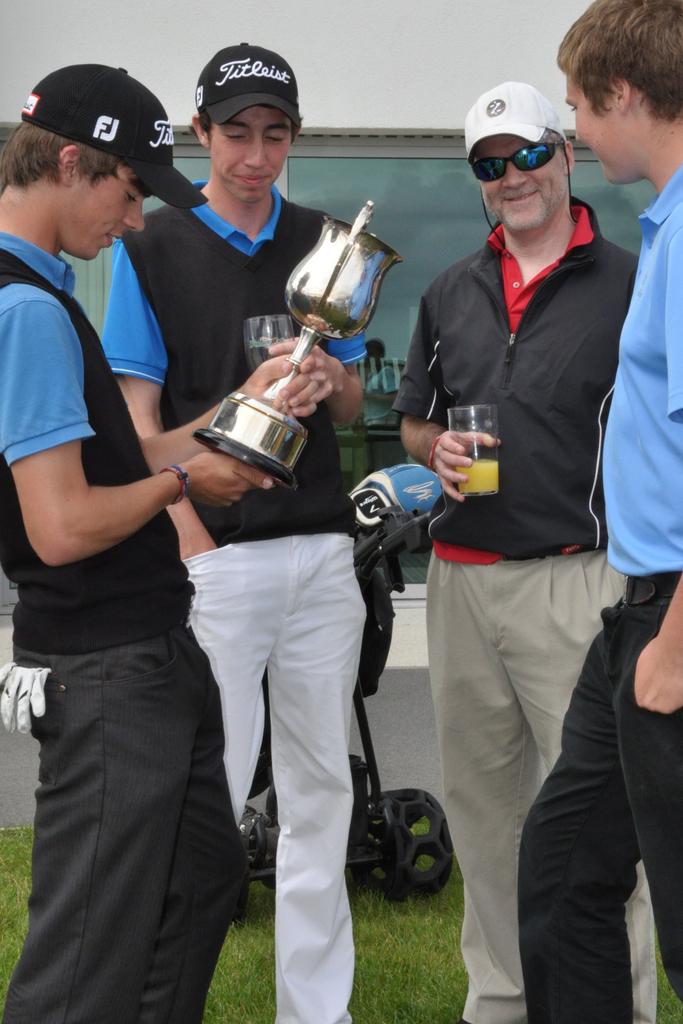What is the brand hat he is wearing?
Give a very brief answer. Titleist. What does it write in the hat?
Give a very brief answer. Titleist. 